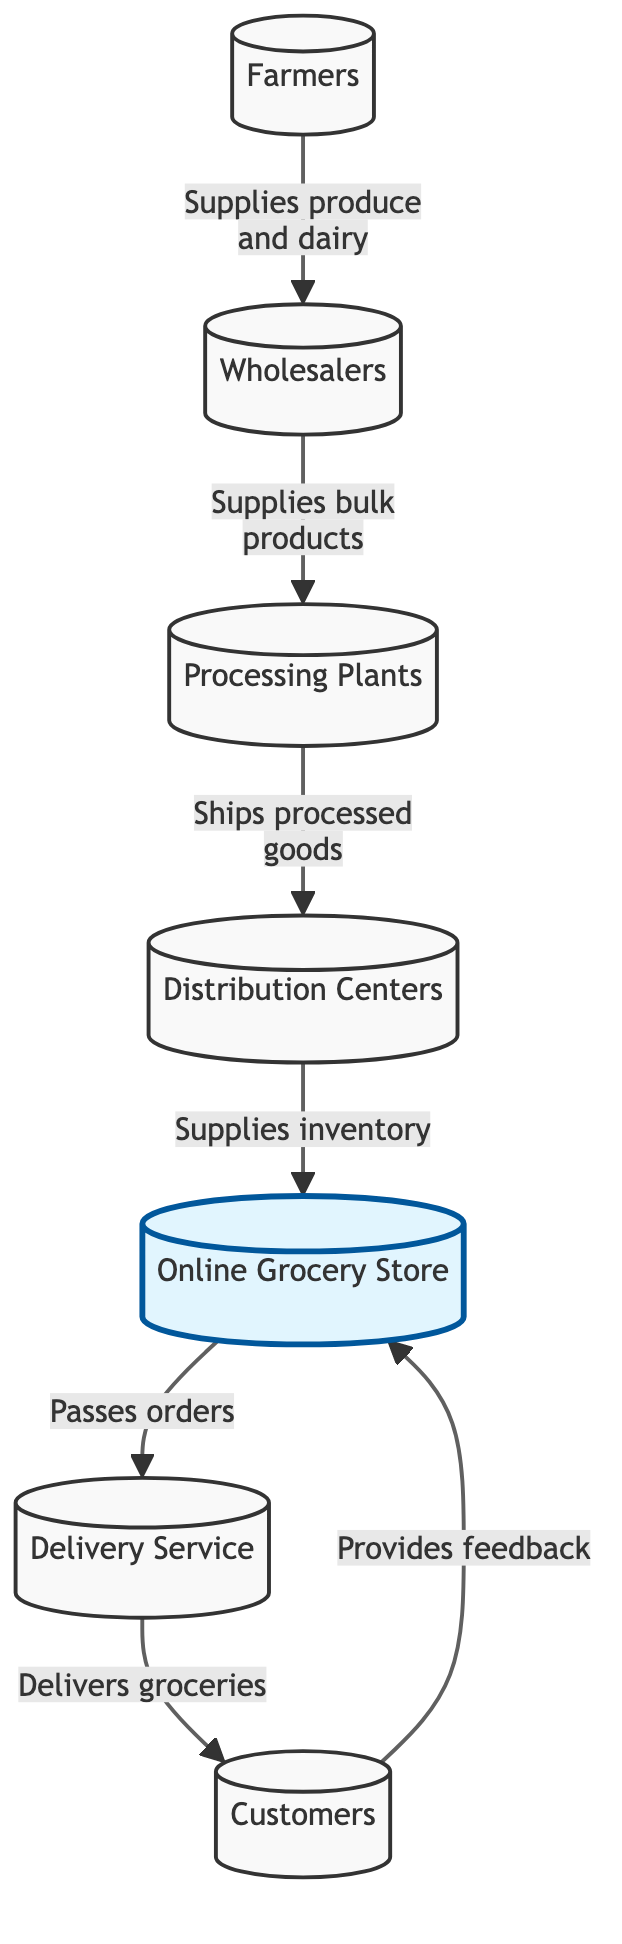What is the first node in the supply chain? The first node in the supply chain is labeled "Farmers", which is where the supply of produce and dairy begins in the flow diagram.
Answer: Farmers How many nodes are in the supply chain diagram? By counting all the distinct entities shown in the diagram, there are a total of seven nodes represented.
Answer: 7 What does the "Wholesalers" node supply? The "Wholesalers" node supplies bulk products to the "Processing Plants" as indicated in the relationship line connecting these two nodes.
Answer: Bulk products What is the last node in the supply chain? The last node in the supply chain is labeled "Customers", which receives the delivered groceries from the delivery service.
Answer: Customers What role does the "Distribution Centers" node play? The "Distribution Centers" node plays the role of supplying inventory to the "Online Grocery Store" in the flow of the supply chain.
Answer: Supplies inventory How does the "Online Grocery Store" communicate with the "Delivery Service"? The "Online Grocery Store" communicates with the "Delivery Service" by passing orders, allowing for the delivery of groceries.
Answer: Passes orders What feedback do "Customers" provide? "Customers" provide feedback to the "Online Grocery Store" regarding their shopping experience, which could help improve services and products offered.
Answer: Provides feedback Which node connects "Processing Plants" and "Distribution Centers"? The "Distribution Centers" node is the one that receives shipped processed goods from the "Processing Plants", establishing a direct connection in the diagram.
Answer: Distribution Centers What does the "Delivery Service" deliver? The "Delivery Service" delivers groceries, which are ordered from the "Online Grocery Store" and sent directly to the customers.
Answer: Delivers groceries 